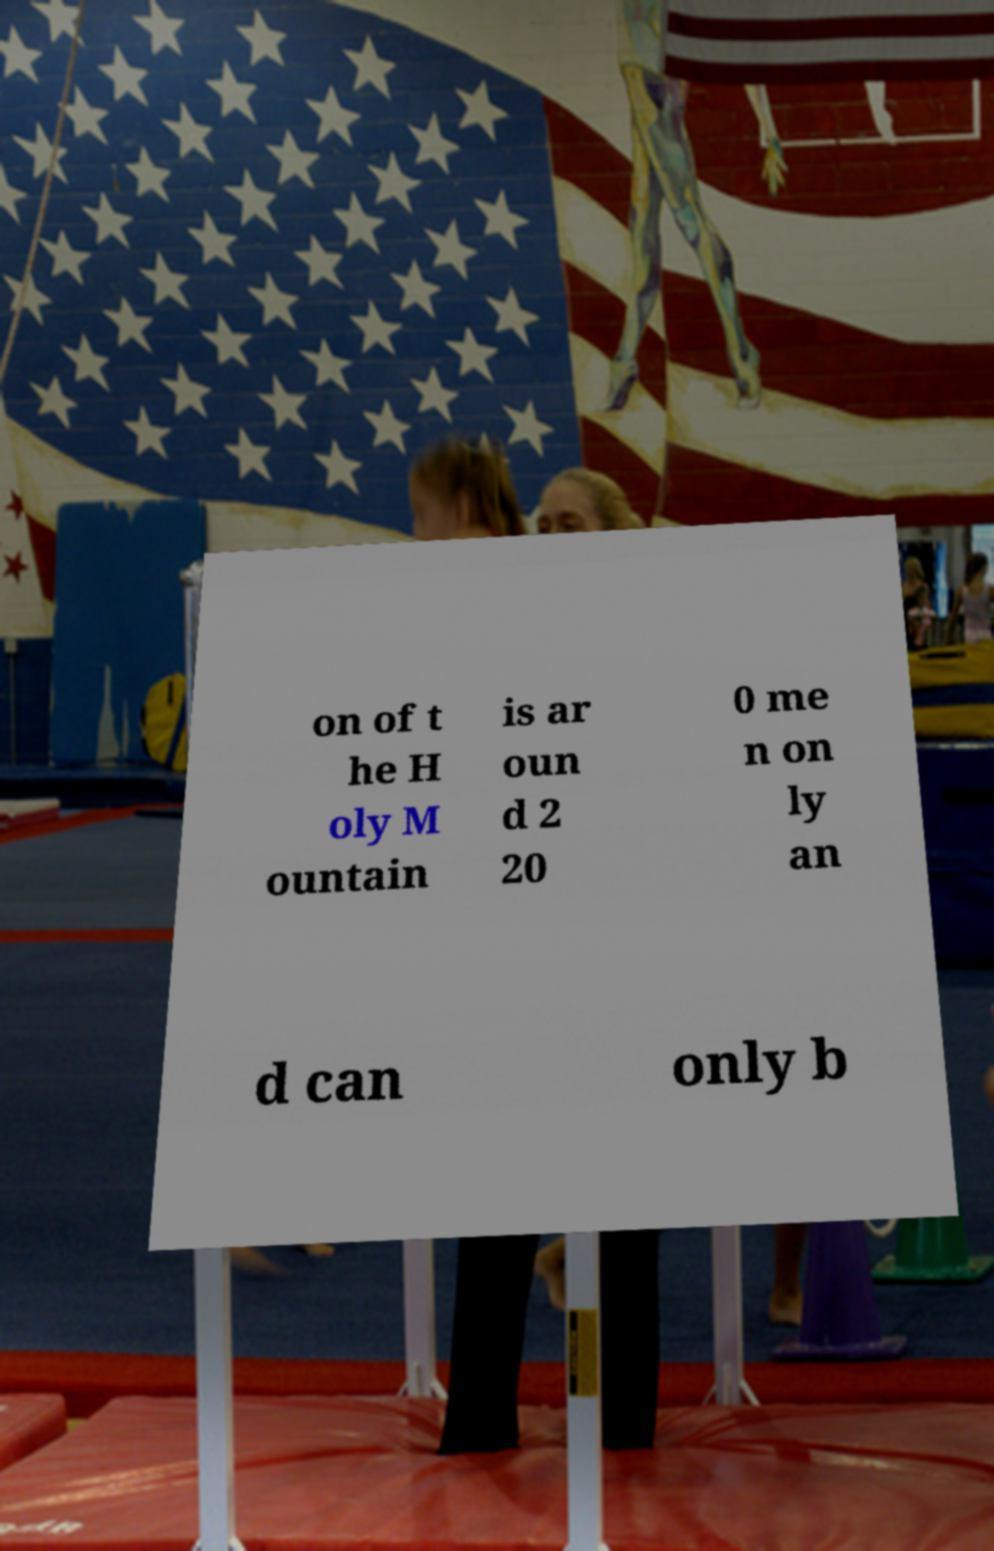I need the written content from this picture converted into text. Can you do that? on of t he H oly M ountain is ar oun d 2 20 0 me n on ly an d can only b 